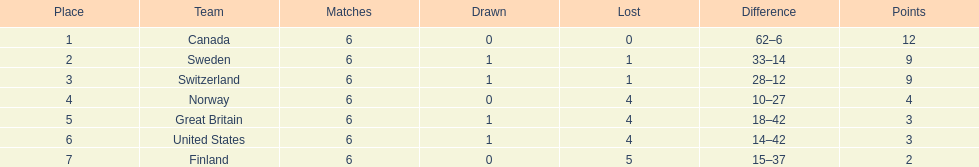What team placed next after sweden? Switzerland. 